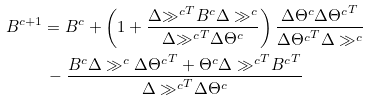<formula> <loc_0><loc_0><loc_500><loc_500>B ^ { c + 1 } & = B ^ { c } + \left ( 1 + \frac { \Delta { \gg ^ { c } } ^ { T } B ^ { c } \Delta \gg ^ { c } } { \Delta { \gg ^ { c } } ^ { T } \Delta \Theta ^ { c } } \right ) \frac { \Delta \Theta ^ { c } { \Delta \Theta ^ { c } } ^ { T } } { { \Delta \Theta ^ { c } } ^ { T } \Delta \gg ^ { c } } \\ & \, - \frac { B ^ { c } \Delta \gg ^ { c } { \Delta \Theta ^ { c } } ^ { T } + \Theta ^ { c } { \Delta \gg ^ { c } } ^ { T } { B ^ { c } } ^ { T } } { { \Delta \gg ^ { c } } ^ { T } \Delta \Theta ^ { c } }</formula> 